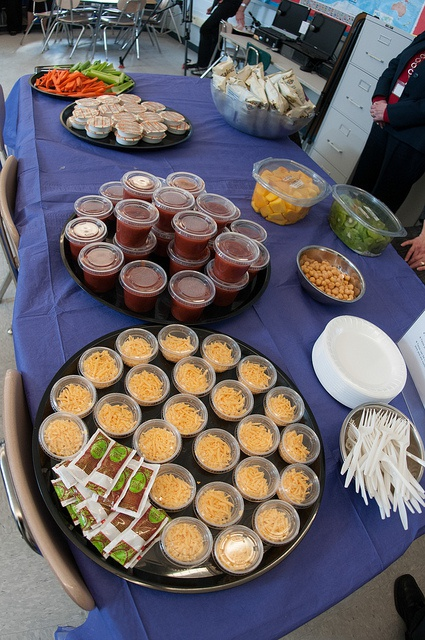Describe the objects in this image and their specific colors. I can see dining table in black, navy, gray, and blue tones, people in black, maroon, gray, and darkgray tones, chair in black, darkgray, tan, and gray tones, bowl in black, lightgray, and darkgray tones, and fork in black, lightgray, darkgray, navy, and gray tones in this image. 